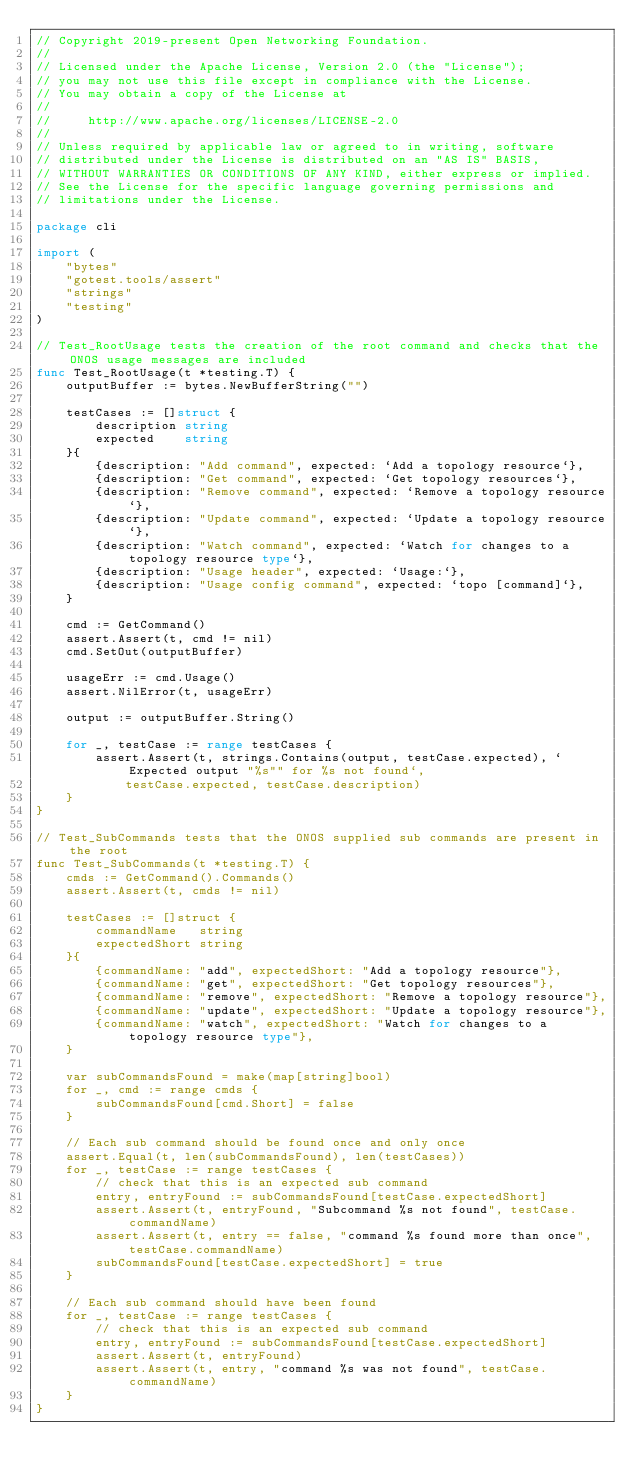Convert code to text. <code><loc_0><loc_0><loc_500><loc_500><_Go_>// Copyright 2019-present Open Networking Foundation.
//
// Licensed under the Apache License, Version 2.0 (the "License");
// you may not use this file except in compliance with the License.
// You may obtain a copy of the License at
//
//     http://www.apache.org/licenses/LICENSE-2.0
//
// Unless required by applicable law or agreed to in writing, software
// distributed under the License is distributed on an "AS IS" BASIS,
// WITHOUT WARRANTIES OR CONDITIONS OF ANY KIND, either express or implied.
// See the License for the specific language governing permissions and
// limitations under the License.

package cli

import (
	"bytes"
	"gotest.tools/assert"
	"strings"
	"testing"
)

// Test_RootUsage tests the creation of the root command and checks that the ONOS usage messages are included
func Test_RootUsage(t *testing.T) {
	outputBuffer := bytes.NewBufferString("")

	testCases := []struct {
		description string
		expected    string
	}{
		{description: "Add command", expected: `Add a topology resource`},
		{description: "Get command", expected: `Get topology resources`},
		{description: "Remove command", expected: `Remove a topology resource`},
		{description: "Update command", expected: `Update a topology resource`},
		{description: "Watch command", expected: `Watch for changes to a topology resource type`},
		{description: "Usage header", expected: `Usage:`},
		{description: "Usage config command", expected: `topo [command]`},
	}

	cmd := GetCommand()
	assert.Assert(t, cmd != nil)
	cmd.SetOut(outputBuffer)

	usageErr := cmd.Usage()
	assert.NilError(t, usageErr)

	output := outputBuffer.String()

	for _, testCase := range testCases {
		assert.Assert(t, strings.Contains(output, testCase.expected), `Expected output "%s"" for %s not found`,
			testCase.expected, testCase.description)
	}
}

// Test_SubCommands tests that the ONOS supplied sub commands are present in the root
func Test_SubCommands(t *testing.T) {
	cmds := GetCommand().Commands()
	assert.Assert(t, cmds != nil)

	testCases := []struct {
		commandName   string
		expectedShort string
	}{
		{commandName: "add", expectedShort: "Add a topology resource"},
		{commandName: "get", expectedShort: "Get topology resources"},
		{commandName: "remove", expectedShort: "Remove a topology resource"},
		{commandName: "update", expectedShort: "Update a topology resource"},
		{commandName: "watch", expectedShort: "Watch for changes to a topology resource type"},
	}

	var subCommandsFound = make(map[string]bool)
	for _, cmd := range cmds {
		subCommandsFound[cmd.Short] = false
	}

	// Each sub command should be found once and only once
	assert.Equal(t, len(subCommandsFound), len(testCases))
	for _, testCase := range testCases {
		// check that this is an expected sub command
		entry, entryFound := subCommandsFound[testCase.expectedShort]
		assert.Assert(t, entryFound, "Subcommand %s not found", testCase.commandName)
		assert.Assert(t, entry == false, "command %s found more than once", testCase.commandName)
		subCommandsFound[testCase.expectedShort] = true
	}

	// Each sub command should have been found
	for _, testCase := range testCases {
		// check that this is an expected sub command
		entry, entryFound := subCommandsFound[testCase.expectedShort]
		assert.Assert(t, entryFound)
		assert.Assert(t, entry, "command %s was not found", testCase.commandName)
	}
}
</code> 